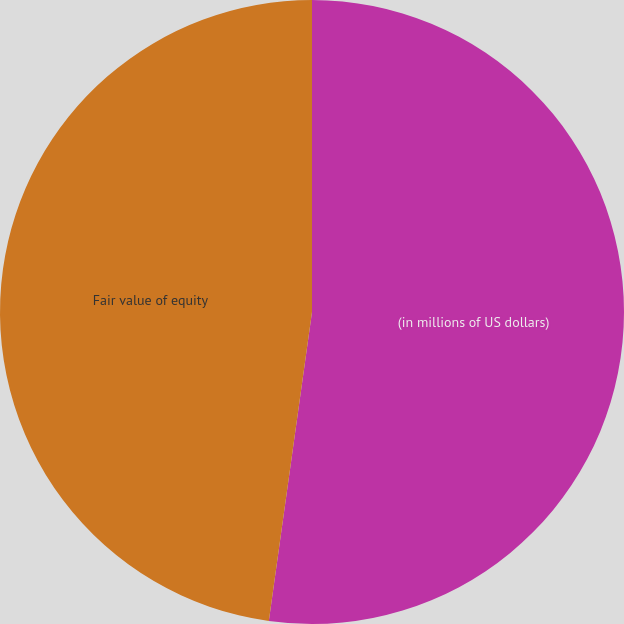Convert chart to OTSL. <chart><loc_0><loc_0><loc_500><loc_500><pie_chart><fcel>(in millions of US dollars)<fcel>Fair value of equity<nl><fcel>52.21%<fcel>47.79%<nl></chart> 